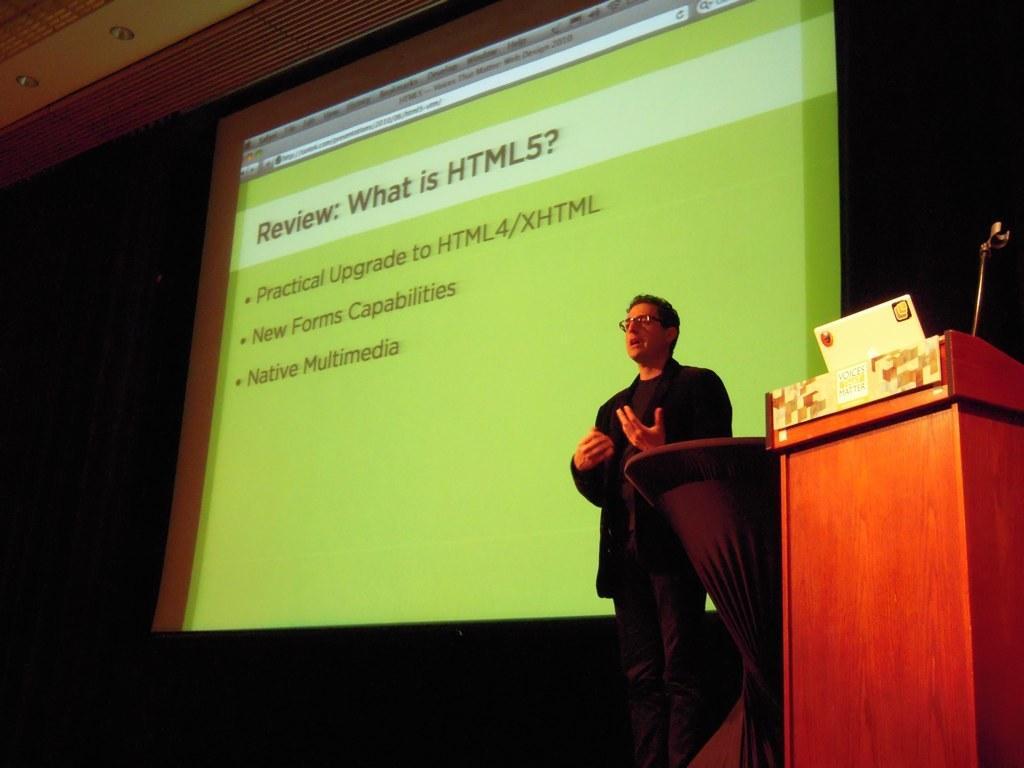Could you give a brief overview of what you see in this image? In the picture we can see a man standing and giving a seminar and bused to the man we can see a desk with a microphone on it and in the background, we can see a screen and some information about the HTML5 and to the ceiling we can see a light. 